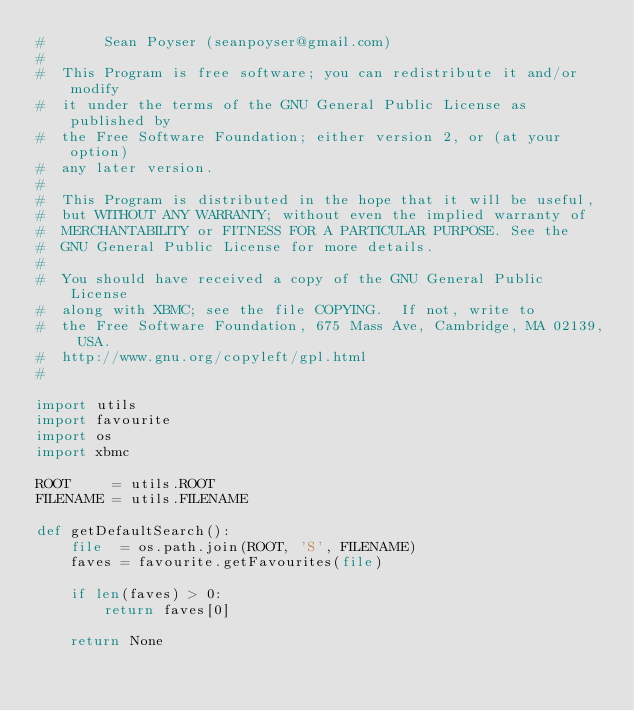<code> <loc_0><loc_0><loc_500><loc_500><_Python_>#       Sean Poyser (seanpoyser@gmail.com)
#
#  This Program is free software; you can redistribute it and/or modify
#  it under the terms of the GNU General Public License as published by
#  the Free Software Foundation; either version 2, or (at your option)
#  any later version.
#
#  This Program is distributed in the hope that it will be useful,
#  but WITHOUT ANY WARRANTY; without even the implied warranty of
#  MERCHANTABILITY or FITNESS FOR A PARTICULAR PURPOSE. See the
#  GNU General Public License for more details.
#
#  You should have received a copy of the GNU General Public License
#  along with XBMC; see the file COPYING.  If not, write to
#  the Free Software Foundation, 675 Mass Ave, Cambridge, MA 02139, USA.
#  http://www.gnu.org/copyleft/gpl.html
#

import utils
import favourite
import os
import xbmc

ROOT     = utils.ROOT
FILENAME = utils.FILENAME

def getDefaultSearch():
    file  = os.path.join(ROOT, 'S', FILENAME)
    faves = favourite.getFavourites(file)

    if len(faves) > 0:
        return faves[0]
    
    return None

</code> 